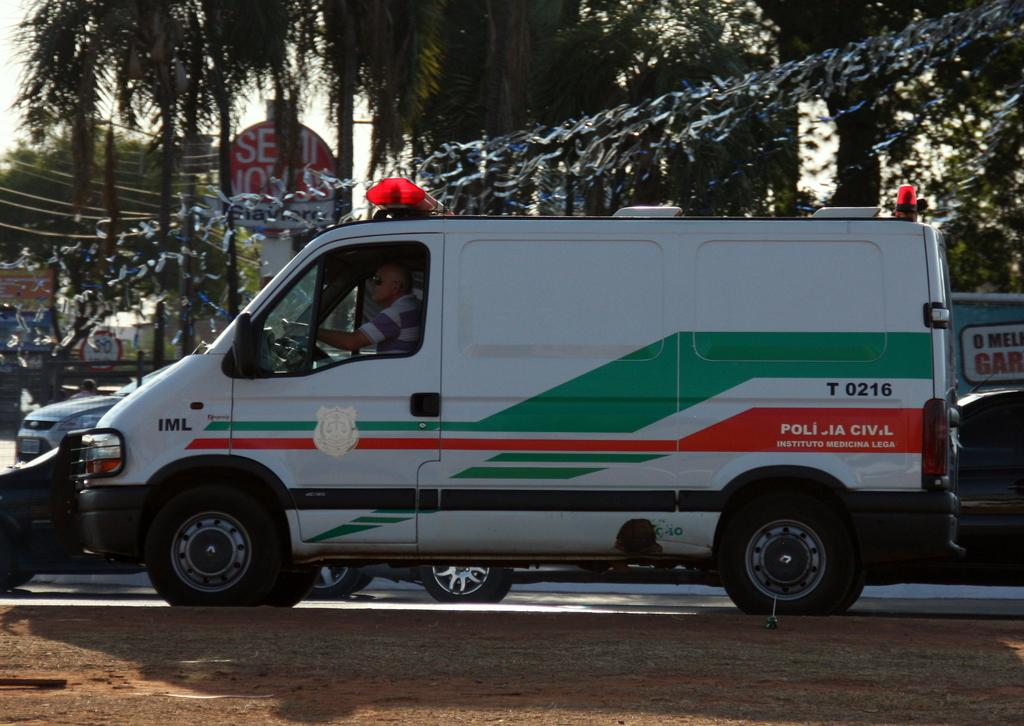<image>
Describe the image concisely. An emergency vehicle is labeled T 2016 and has lights on top. 